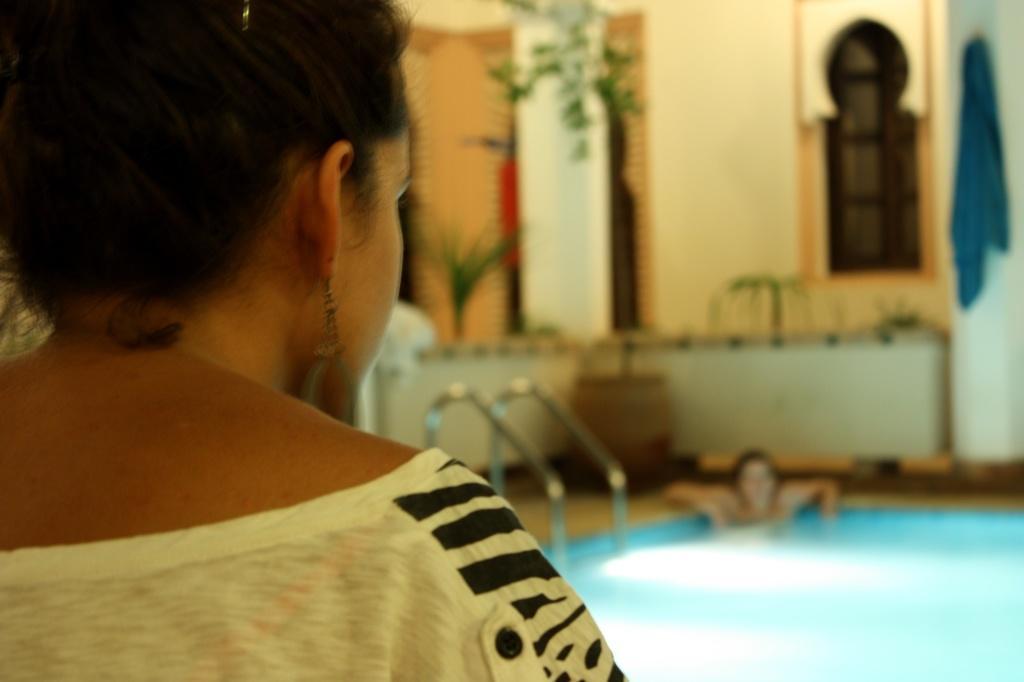Could you give a brief overview of what you see in this image? In this image I can see a person wearing white and black colored dress and in the background I can see a swimming pool, a person in the pool, the wall, a plant, a blue colored cloth and few other objects. 